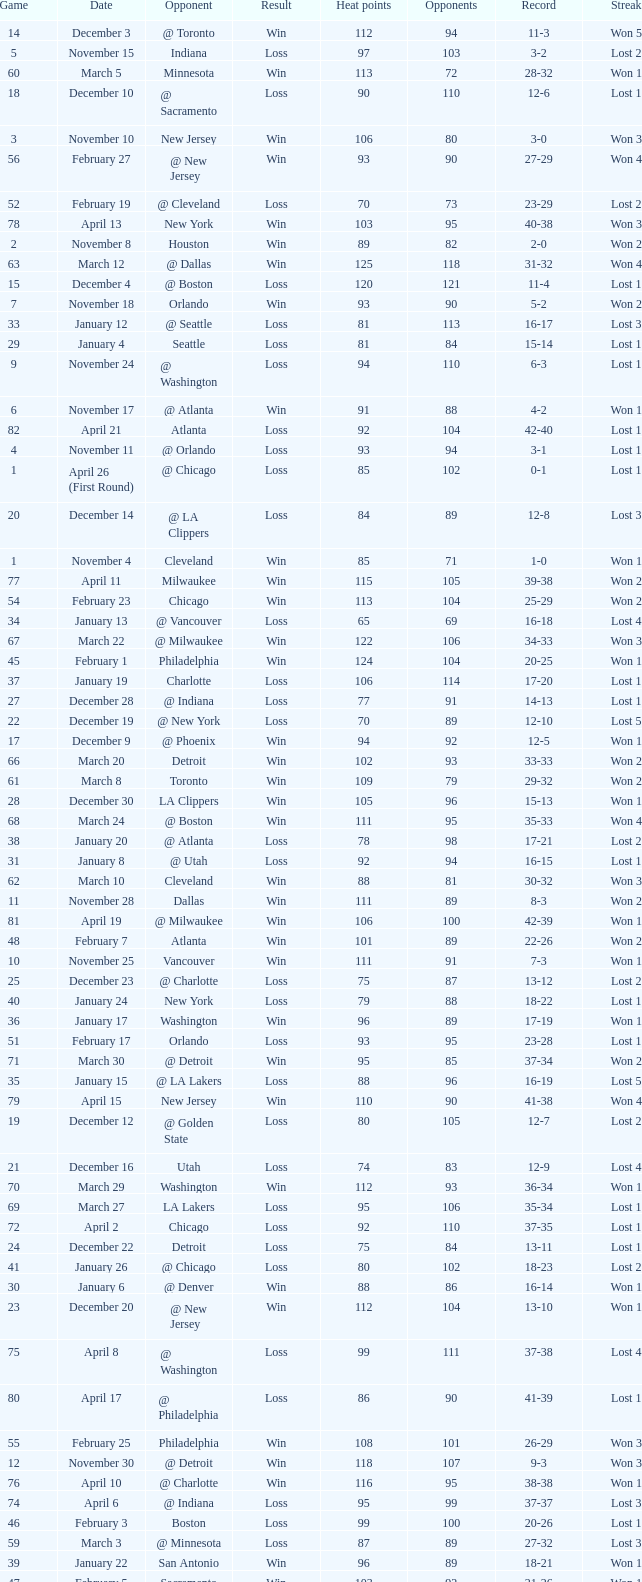What is Streak, when Heat Points is "101", and when Game is "16"? Lost 2. 